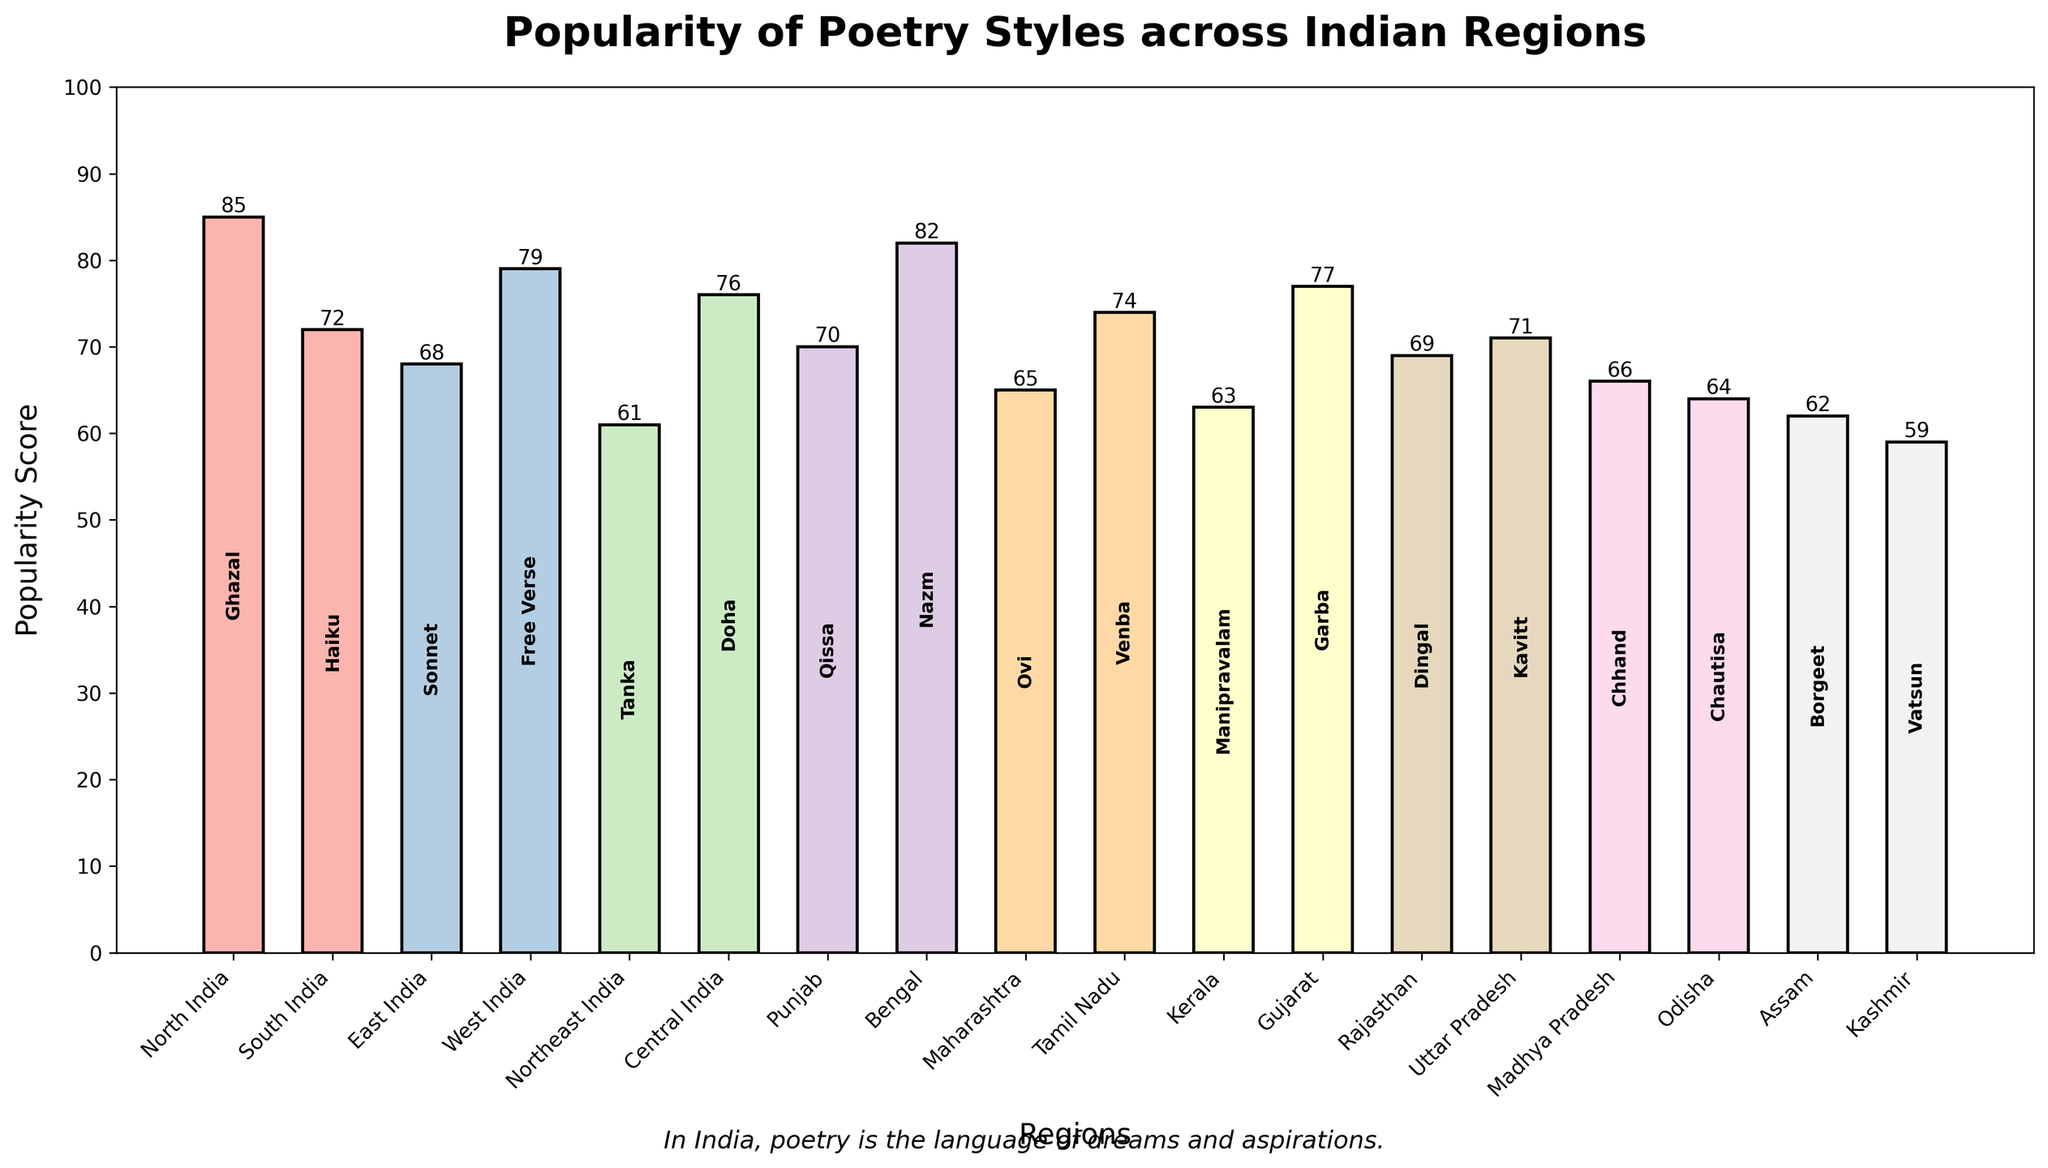Which region has the highest popularity score for a poetry style? Look for the bar that reaches the highest value on the y-axis. The highest bar corresponds to the region with the highest popularity score.
Answer: North India What is the difference in popularity scores between the poetry styles in North India and South India? The popularity score for North India is 85 and for South India is 72. Subtract 72 from 85 to get the difference.
Answer: 13 Which region has the least popular poetry style? Identify the shortest bar in the chart, which indicates the region with the lowest popularity score.
Answer: Kashmir How many regions have a popularity score above 70? Count the number of bars with heights above the 70 mark on the y-axis. Check the scores shown on top of each bar for verification.
Answer: 8 Compare the popularity scores of Free Verse and Garba. Which one is more popular? Find the regions corresponding to Free Verse (West India) and Garba (Gujarat) and compare their heights. Free Verse's score is 79 while Garba’s score is 77.
Answer: Free Verse What is the average popularity score of the poetry styles in North India and Bengal? The popularity scores for North India and Bengal are 85 and 82, respectively. Sum them up (85 + 82) and divide by 2 to find the average.
Answer: 83.5 Which poetry style is associated with Tamil Nadu and what is its popularity score? Look for the region Tamil Nadu and check the label inside the bar for the poetry style. The score is shown on top of the bar.
Answer: Venba, 74 How does the popularity of the poetry style in Kerala compare to that in Maharashtra? Compare the heights of the bars for Kerala (Manipravalam, score 63) and Maharashtra (Ovi, score 65). Determine which is higher or if they are equal.
Answer: Maharashtra is more popular Which region has a popularity score that is exactly equal to the median score of all regions? To find the median, list all popularity scores in ascending order and find the middle value. The exact median score here is 68. Identify the region with this score which is East India.
Answer: East India What is the total popularity score for the poetry styles in Punjab, Bengal, and Maharashtra combined? Add together the popularity scores for these regions: Punjab (70), Bengal (82), and Maharashtra (65).
Answer: 217 